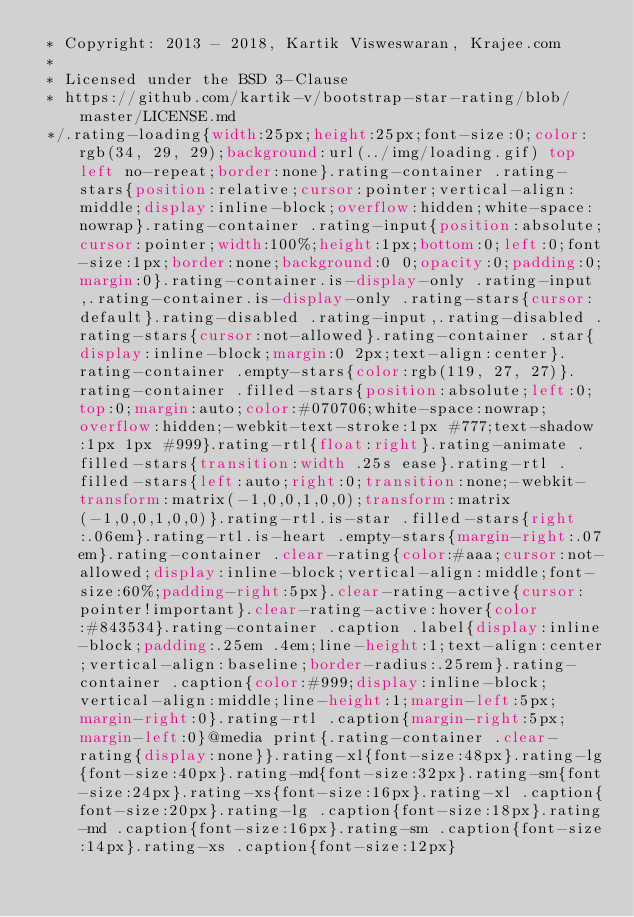Convert code to text. <code><loc_0><loc_0><loc_500><loc_500><_CSS_> * Copyright: 2013 - 2018, Kartik Visweswaran, Krajee.com
 *
 * Licensed under the BSD 3-Clause
 * https://github.com/kartik-v/bootstrap-star-rating/blob/master/LICENSE.md
 */.rating-loading{width:25px;height:25px;font-size:0;color:rgb(34, 29, 29);background:url(../img/loading.gif) top left no-repeat;border:none}.rating-container .rating-stars{position:relative;cursor:pointer;vertical-align:middle;display:inline-block;overflow:hidden;white-space:nowrap}.rating-container .rating-input{position:absolute;cursor:pointer;width:100%;height:1px;bottom:0;left:0;font-size:1px;border:none;background:0 0;opacity:0;padding:0;margin:0}.rating-container.is-display-only .rating-input,.rating-container.is-display-only .rating-stars{cursor:default}.rating-disabled .rating-input,.rating-disabled .rating-stars{cursor:not-allowed}.rating-container .star{display:inline-block;margin:0 2px;text-align:center}.rating-container .empty-stars{color:rgb(119, 27, 27)}.rating-container .filled-stars{position:absolute;left:0;top:0;margin:auto;color:#070706;white-space:nowrap;overflow:hidden;-webkit-text-stroke:1px #777;text-shadow:1px 1px #999}.rating-rtl{float:right}.rating-animate .filled-stars{transition:width .25s ease}.rating-rtl .filled-stars{left:auto;right:0;transition:none;-webkit-transform:matrix(-1,0,0,1,0,0);transform:matrix(-1,0,0,1,0,0)}.rating-rtl.is-star .filled-stars{right:.06em}.rating-rtl.is-heart .empty-stars{margin-right:.07em}.rating-container .clear-rating{color:#aaa;cursor:not-allowed;display:inline-block;vertical-align:middle;font-size:60%;padding-right:5px}.clear-rating-active{cursor:pointer!important}.clear-rating-active:hover{color:#843534}.rating-container .caption .label{display:inline-block;padding:.25em .4em;line-height:1;text-align:center;vertical-align:baseline;border-radius:.25rem}.rating-container .caption{color:#999;display:inline-block;vertical-align:middle;line-height:1;margin-left:5px;margin-right:0}.rating-rtl .caption{margin-right:5px;margin-left:0}@media print{.rating-container .clear-rating{display:none}}.rating-xl{font-size:48px}.rating-lg{font-size:40px}.rating-md{font-size:32px}.rating-sm{font-size:24px}.rating-xs{font-size:16px}.rating-xl .caption{font-size:20px}.rating-lg .caption{font-size:18px}.rating-md .caption{font-size:16px}.rating-sm .caption{font-size:14px}.rating-xs .caption{font-size:12px}</code> 